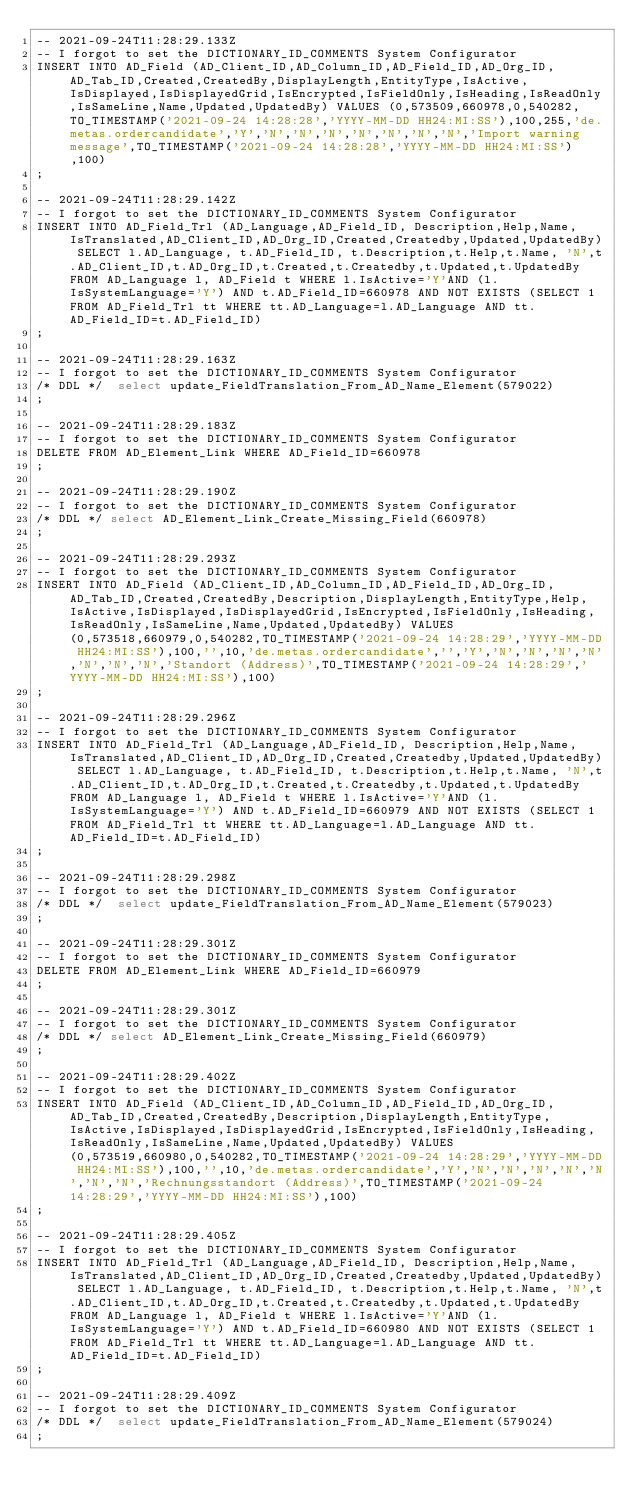Convert code to text. <code><loc_0><loc_0><loc_500><loc_500><_SQL_>-- 2021-09-24T11:28:29.133Z
-- I forgot to set the DICTIONARY_ID_COMMENTS System Configurator
INSERT INTO AD_Field (AD_Client_ID,AD_Column_ID,AD_Field_ID,AD_Org_ID,AD_Tab_ID,Created,CreatedBy,DisplayLength,EntityType,IsActive,IsDisplayed,IsDisplayedGrid,IsEncrypted,IsFieldOnly,IsHeading,IsReadOnly,IsSameLine,Name,Updated,UpdatedBy) VALUES (0,573509,660978,0,540282,TO_TIMESTAMP('2021-09-24 14:28:28','YYYY-MM-DD HH24:MI:SS'),100,255,'de.metas.ordercandidate','Y','N','N','N','N','N','N','N','Import warning message',TO_TIMESTAMP('2021-09-24 14:28:28','YYYY-MM-DD HH24:MI:SS'),100)
;

-- 2021-09-24T11:28:29.142Z
-- I forgot to set the DICTIONARY_ID_COMMENTS System Configurator
INSERT INTO AD_Field_Trl (AD_Language,AD_Field_ID, Description,Help,Name, IsTranslated,AD_Client_ID,AD_Org_ID,Created,Createdby,Updated,UpdatedBy) SELECT l.AD_Language, t.AD_Field_ID, t.Description,t.Help,t.Name, 'N',t.AD_Client_ID,t.AD_Org_ID,t.Created,t.Createdby,t.Updated,t.UpdatedBy FROM AD_Language l, AD_Field t WHERE l.IsActive='Y'AND (l.IsSystemLanguage='Y') AND t.AD_Field_ID=660978 AND NOT EXISTS (SELECT 1 FROM AD_Field_Trl tt WHERE tt.AD_Language=l.AD_Language AND tt.AD_Field_ID=t.AD_Field_ID)
;

-- 2021-09-24T11:28:29.163Z
-- I forgot to set the DICTIONARY_ID_COMMENTS System Configurator
/* DDL */  select update_FieldTranslation_From_AD_Name_Element(579022) 
;

-- 2021-09-24T11:28:29.183Z
-- I forgot to set the DICTIONARY_ID_COMMENTS System Configurator
DELETE FROM AD_Element_Link WHERE AD_Field_ID=660978
;

-- 2021-09-24T11:28:29.190Z
-- I forgot to set the DICTIONARY_ID_COMMENTS System Configurator
/* DDL */ select AD_Element_Link_Create_Missing_Field(660978)
;

-- 2021-09-24T11:28:29.293Z
-- I forgot to set the DICTIONARY_ID_COMMENTS System Configurator
INSERT INTO AD_Field (AD_Client_ID,AD_Column_ID,AD_Field_ID,AD_Org_ID,AD_Tab_ID,Created,CreatedBy,Description,DisplayLength,EntityType,Help,IsActive,IsDisplayed,IsDisplayedGrid,IsEncrypted,IsFieldOnly,IsHeading,IsReadOnly,IsSameLine,Name,Updated,UpdatedBy) VALUES (0,573518,660979,0,540282,TO_TIMESTAMP('2021-09-24 14:28:29','YYYY-MM-DD HH24:MI:SS'),100,'',10,'de.metas.ordercandidate','','Y','N','N','N','N','N','N','N','Standort (Address)',TO_TIMESTAMP('2021-09-24 14:28:29','YYYY-MM-DD HH24:MI:SS'),100)
;

-- 2021-09-24T11:28:29.296Z
-- I forgot to set the DICTIONARY_ID_COMMENTS System Configurator
INSERT INTO AD_Field_Trl (AD_Language,AD_Field_ID, Description,Help,Name, IsTranslated,AD_Client_ID,AD_Org_ID,Created,Createdby,Updated,UpdatedBy) SELECT l.AD_Language, t.AD_Field_ID, t.Description,t.Help,t.Name, 'N',t.AD_Client_ID,t.AD_Org_ID,t.Created,t.Createdby,t.Updated,t.UpdatedBy FROM AD_Language l, AD_Field t WHERE l.IsActive='Y'AND (l.IsSystemLanguage='Y') AND t.AD_Field_ID=660979 AND NOT EXISTS (SELECT 1 FROM AD_Field_Trl tt WHERE tt.AD_Language=l.AD_Language AND tt.AD_Field_ID=t.AD_Field_ID)
;

-- 2021-09-24T11:28:29.298Z
-- I forgot to set the DICTIONARY_ID_COMMENTS System Configurator
/* DDL */  select update_FieldTranslation_From_AD_Name_Element(579023) 
;

-- 2021-09-24T11:28:29.301Z
-- I forgot to set the DICTIONARY_ID_COMMENTS System Configurator
DELETE FROM AD_Element_Link WHERE AD_Field_ID=660979
;

-- 2021-09-24T11:28:29.301Z
-- I forgot to set the DICTIONARY_ID_COMMENTS System Configurator
/* DDL */ select AD_Element_Link_Create_Missing_Field(660979)
;

-- 2021-09-24T11:28:29.402Z
-- I forgot to set the DICTIONARY_ID_COMMENTS System Configurator
INSERT INTO AD_Field (AD_Client_ID,AD_Column_ID,AD_Field_ID,AD_Org_ID,AD_Tab_ID,Created,CreatedBy,Description,DisplayLength,EntityType,IsActive,IsDisplayed,IsDisplayedGrid,IsEncrypted,IsFieldOnly,IsHeading,IsReadOnly,IsSameLine,Name,Updated,UpdatedBy) VALUES (0,573519,660980,0,540282,TO_TIMESTAMP('2021-09-24 14:28:29','YYYY-MM-DD HH24:MI:SS'),100,'',10,'de.metas.ordercandidate','Y','N','N','N','N','N','N','N','Rechnungsstandort (Address)',TO_TIMESTAMP('2021-09-24 14:28:29','YYYY-MM-DD HH24:MI:SS'),100)
;

-- 2021-09-24T11:28:29.405Z
-- I forgot to set the DICTIONARY_ID_COMMENTS System Configurator
INSERT INTO AD_Field_Trl (AD_Language,AD_Field_ID, Description,Help,Name, IsTranslated,AD_Client_ID,AD_Org_ID,Created,Createdby,Updated,UpdatedBy) SELECT l.AD_Language, t.AD_Field_ID, t.Description,t.Help,t.Name, 'N',t.AD_Client_ID,t.AD_Org_ID,t.Created,t.Createdby,t.Updated,t.UpdatedBy FROM AD_Language l, AD_Field t WHERE l.IsActive='Y'AND (l.IsSystemLanguage='Y') AND t.AD_Field_ID=660980 AND NOT EXISTS (SELECT 1 FROM AD_Field_Trl tt WHERE tt.AD_Language=l.AD_Language AND tt.AD_Field_ID=t.AD_Field_ID)
;

-- 2021-09-24T11:28:29.409Z
-- I forgot to set the DICTIONARY_ID_COMMENTS System Configurator
/* DDL */  select update_FieldTranslation_From_AD_Name_Element(579024) 
;
</code> 